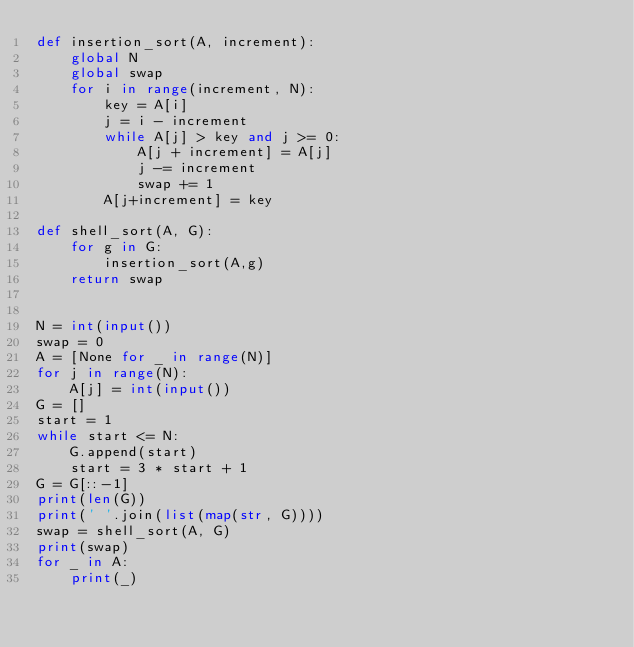Convert code to text. <code><loc_0><loc_0><loc_500><loc_500><_Python_>def insertion_sort(A, increment):
    global N
    global swap
    for i in range(increment, N):
        key = A[i]
        j = i - increment
        while A[j] > key and j >= 0:
            A[j + increment] = A[j]
            j -= increment
            swap += 1
        A[j+increment] = key
    
def shell_sort(A, G): 
    for g in G:
        insertion_sort(A,g)
    return swap
        

N = int(input())
swap = 0 
A = [None for _ in range(N)]
for j in range(N):
    A[j] = int(input())
G = []
start = 1
while start <= N:
    G.append(start)
    start = 3 * start + 1
G = G[::-1]
print(len(G))
print(' '.join(list(map(str, G))))
swap = shell_sort(A, G)
print(swap)
for _ in A:
    print(_)
</code> 